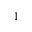Convert formula to latex. <formula><loc_0><loc_0><loc_500><loc_500>^ { 1 }</formula> 